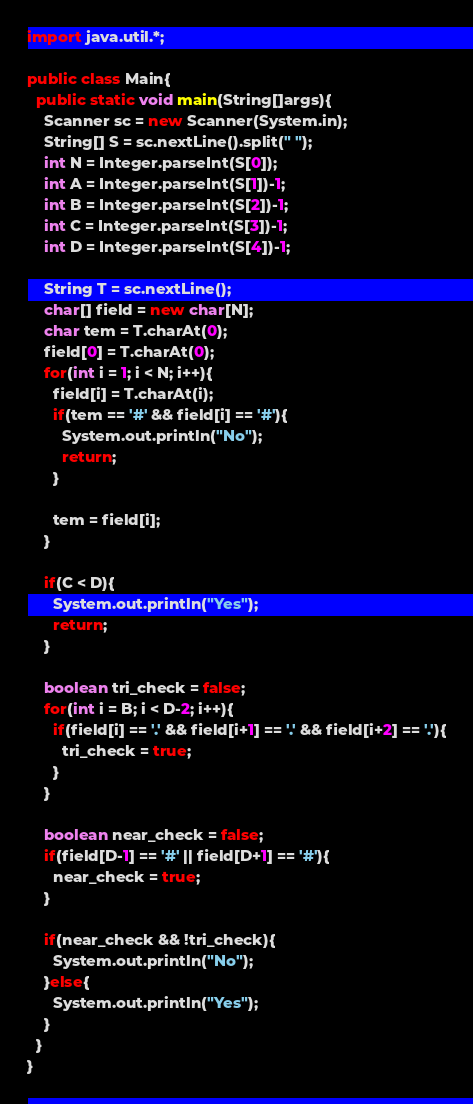<code> <loc_0><loc_0><loc_500><loc_500><_Java_>import java.util.*;

public class Main{
  public static void main(String[]args){
    Scanner sc = new Scanner(System.in);
    String[] S = sc.nextLine().split(" ");
    int N = Integer.parseInt(S[0]);
    int A = Integer.parseInt(S[1])-1;
    int B = Integer.parseInt(S[2])-1;
    int C = Integer.parseInt(S[3])-1;
    int D = Integer.parseInt(S[4])-1;
    
    String T = sc.nextLine();
    char[] field = new char[N];
    char tem = T.charAt(0);
    field[0] = T.charAt(0);
    for(int i = 1; i < N; i++){
      field[i] = T.charAt(i);
      if(tem == '#' && field[i] == '#'){
        System.out.println("No");
        return;
      }
      
      tem = field[i];
    }
    
    if(C < D){
      System.out.println("Yes");
      return;
    }
    
    boolean tri_check = false;
    for(int i = B; i < D-2; i++){
      if(field[i] == '.' && field[i+1] == '.' && field[i+2] == '.'){
        tri_check = true;
      }
    }
    
    boolean near_check = false;
    if(field[D-1] == '#' || field[D+1] == '#'){
      near_check = true;
    }
    
    if(near_check && !tri_check){
      System.out.println("No");
    }else{
      System.out.println("Yes");
    }
  }
}</code> 